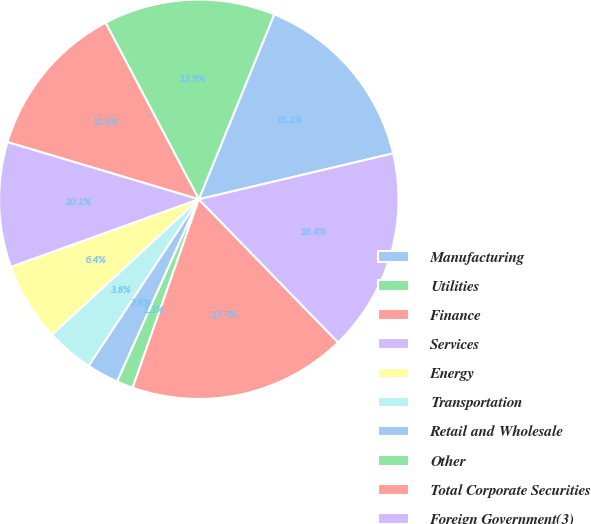Convert chart. <chart><loc_0><loc_0><loc_500><loc_500><pie_chart><fcel>Manufacturing<fcel>Utilities<fcel>Finance<fcel>Services<fcel>Energy<fcel>Transportation<fcel>Retail and Wholesale<fcel>Other<fcel>Total Corporate Securities<fcel>Foreign Government(3)<nl><fcel>15.15%<fcel>13.9%<fcel>12.64%<fcel>10.13%<fcel>6.36%<fcel>3.84%<fcel>2.59%<fcel>1.33%<fcel>17.66%<fcel>16.41%<nl></chart> 